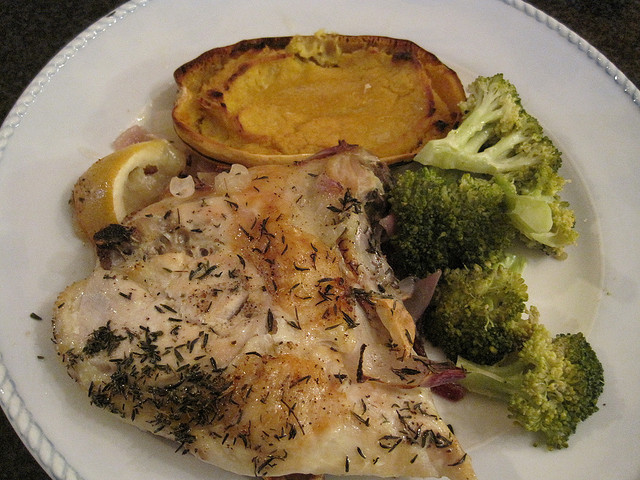<image>What type of cuisine does this represent? It is ambiguous what type of cuisine this represents. It could be Continental, American or French. What type of cuisine does this represent? I don't know what type of cuisine does this represent. It can be dinner, continental, chicken, fish, pork chops, American or French. 